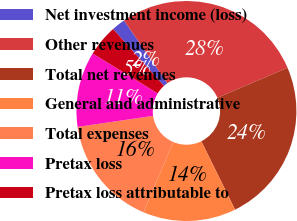<chart> <loc_0><loc_0><loc_500><loc_500><pie_chart><fcel>Net investment income (loss)<fcel>Other revenues<fcel>Total net revenues<fcel>General and administrative<fcel>Total expenses<fcel>Pretax loss<fcel>Pretax loss attributable to<nl><fcel>2.01%<fcel>28.17%<fcel>24.14%<fcel>13.68%<fcel>16.3%<fcel>11.07%<fcel>4.63%<nl></chart> 